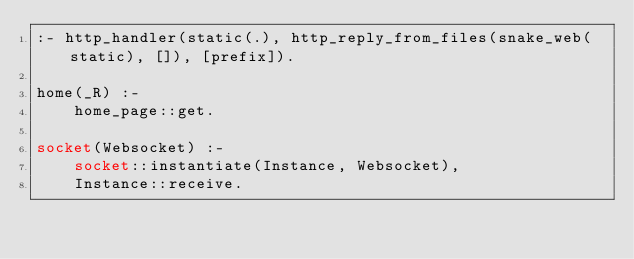<code> <loc_0><loc_0><loc_500><loc_500><_Perl_>:- http_handler(static(.), http_reply_from_files(snake_web(static), []), [prefix]).

home(_R) :-
    home_page::get.

socket(Websocket) :-
    socket::instantiate(Instance, Websocket),
    Instance::receive.
</code> 